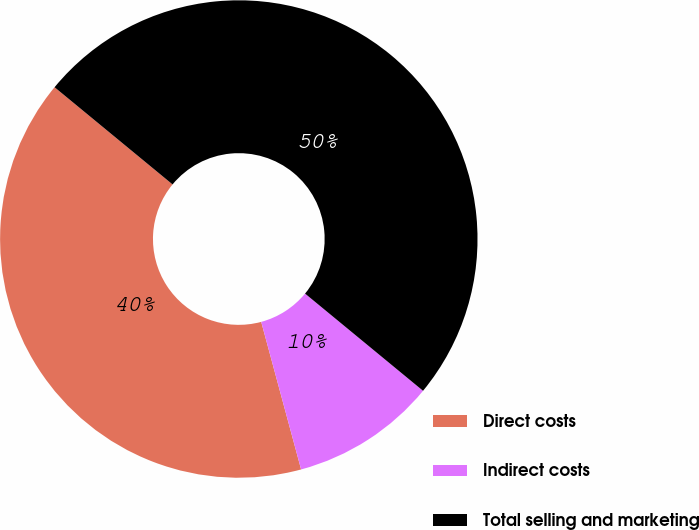Convert chart. <chart><loc_0><loc_0><loc_500><loc_500><pie_chart><fcel>Direct costs<fcel>Indirect costs<fcel>Total selling and marketing<nl><fcel>40.17%<fcel>9.83%<fcel>50.0%<nl></chart> 